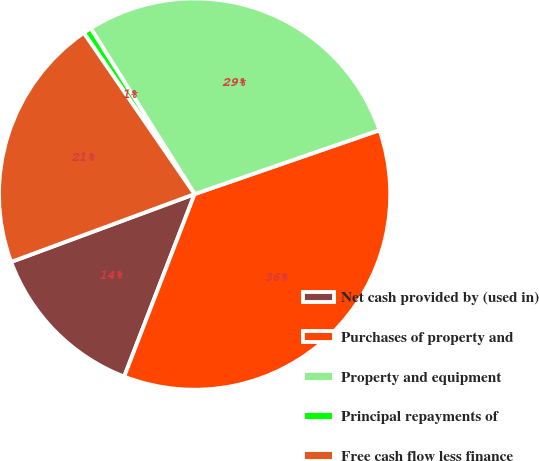<chart> <loc_0><loc_0><loc_500><loc_500><pie_chart><fcel>Net cash provided by (used in)<fcel>Purchases of property and<fcel>Property and equipment<fcel>Principal repayments of<fcel>Free cash flow less finance<nl><fcel>13.5%<fcel>36.16%<fcel>28.61%<fcel>0.68%<fcel>21.05%<nl></chart> 